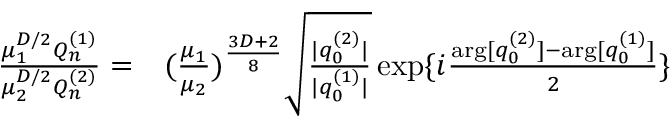<formula> <loc_0><loc_0><loc_500><loc_500>\begin{array} { r l } { \frac { \mu _ { 1 } ^ { D / 2 } Q _ { n } ^ { ( 1 ) } } { \mu _ { 2 } ^ { D / 2 } Q _ { n } ^ { ( 2 ) } } = } & ( \frac { \mu _ { 1 } } { \mu _ { 2 } } ) ^ { \frac { 3 D + 2 } { 8 } } \sqrt { \frac { | q _ { 0 } ^ { ( 2 ) } | } { | q _ { 0 } ^ { ( 1 ) } | } } \exp \{ i \frac { \arg [ q _ { 0 } ^ { ( 2 ) } ] - \arg [ q _ { 0 } ^ { ( 1 ) } ] } { 2 } \} } \end{array}</formula> 